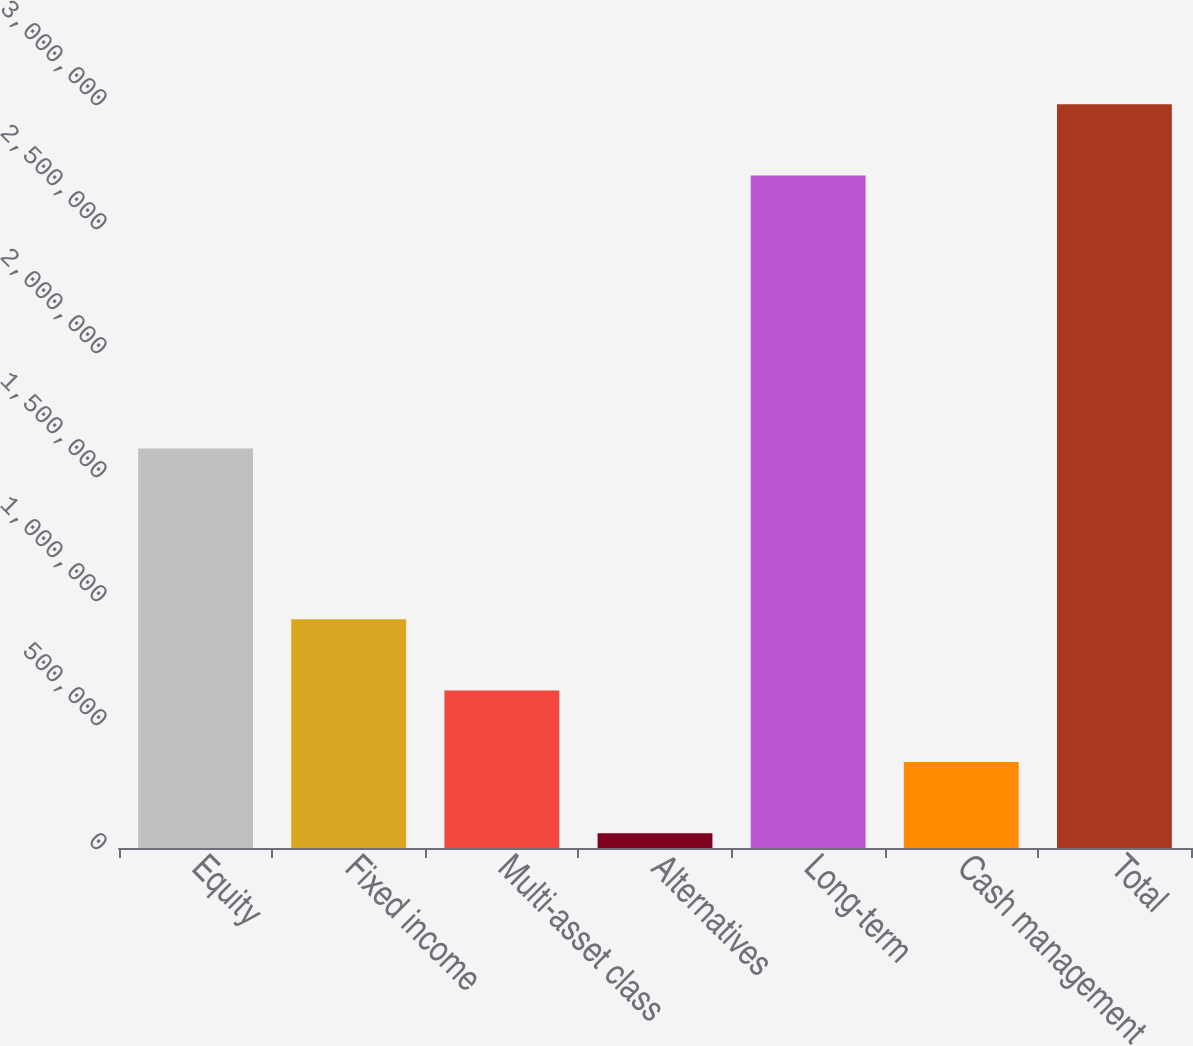Convert chart. <chart><loc_0><loc_0><loc_500><loc_500><bar_chart><fcel>Equity<fcel>Fixed income<fcel>Multi-asset class<fcel>Alternatives<fcel>Long-term<fcel>Cash management<fcel>Total<nl><fcel>1.61078e+06<fcel>922259<fcel>634720<fcel>59644<fcel>2.71158e+06<fcel>347182<fcel>2.99912e+06<nl></chart> 